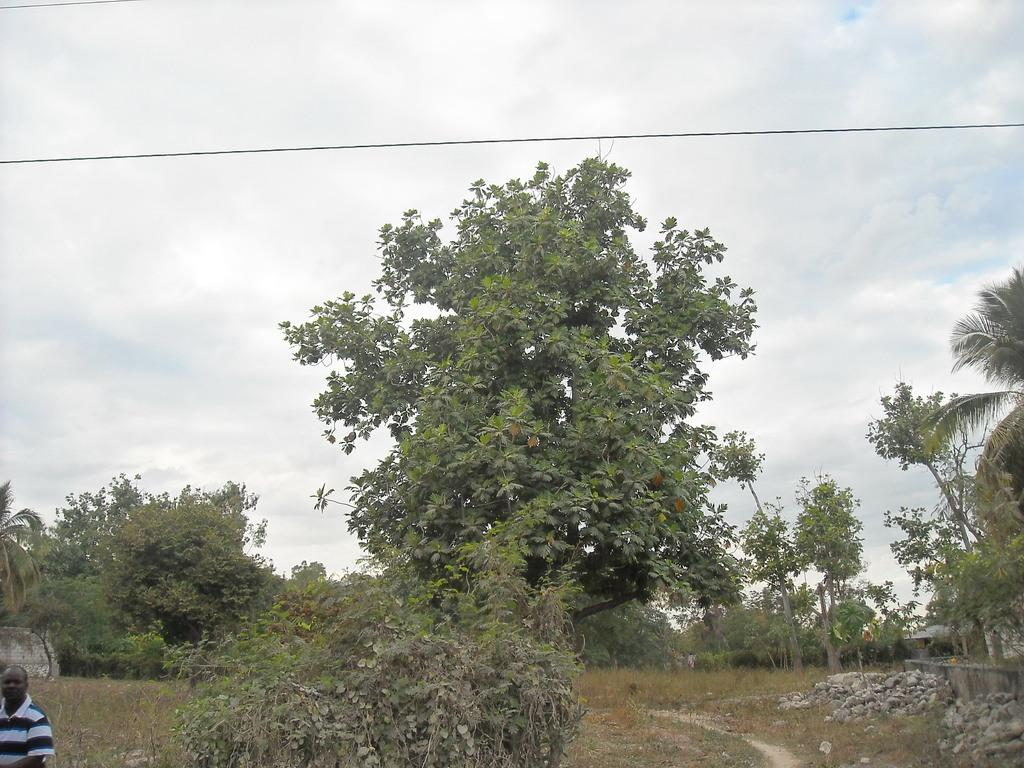What is located on the left bottom of the image? There is a person standing on the left bottom of the image. What can be seen in the background of the image? The sky, clouds, trees, plants, a house, a roof, a wall, and grass are visible in the background of the image. What type of soup is being served in the image? There is no soup present in the image. Can you tell me how many dogs are visible in the image? There are no dogs present in the image. 